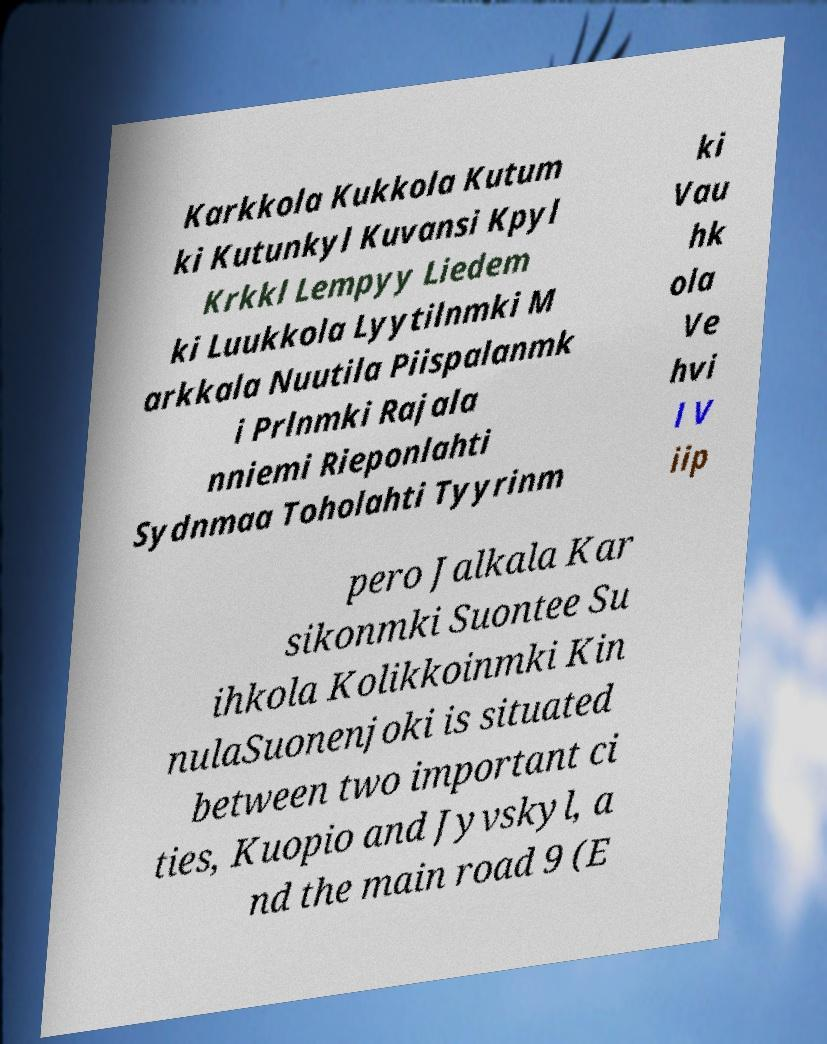Could you assist in decoding the text presented in this image and type it out clearly? Karkkola Kukkola Kutum ki Kutunkyl Kuvansi Kpyl Krkkl Lempyy Liedem ki Luukkola Lyytilnmki M arkkala Nuutila Piispalanmk i Prlnmki Rajala nniemi Rieponlahti Sydnmaa Toholahti Tyyrinm ki Vau hk ola Ve hvi l V iip pero Jalkala Kar sikonmki Suontee Su ihkola Kolikkoinmki Kin nulaSuonenjoki is situated between two important ci ties, Kuopio and Jyvskyl, a nd the main road 9 (E 